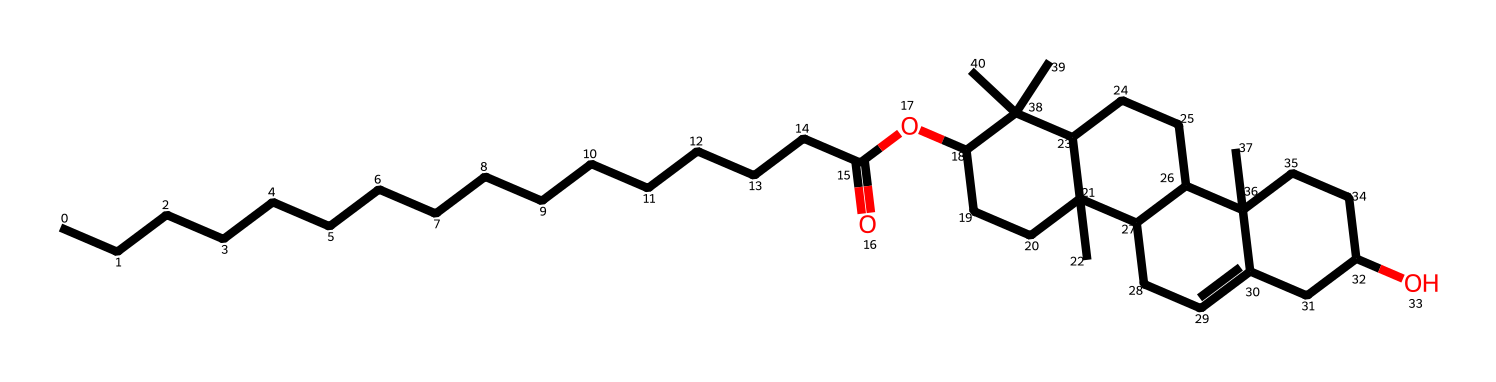What is the molecular formula of the chemical based on its structure? To deduce the molecular formula, count the number of each type of atom visible in the SMILES representation. For this structure, count the number of carbon (C), hydrogen (H), and oxygen (O) atoms, which totals to C30H50O2.
Answer: C30H50O2 How many rings are present in the chemical structure? Examine the structure to identify the presence of cyclic structures. The SMILES notation features multiple "C" that indicate cycles, and upon visualization, there are three distinct rings in the structure.
Answer: 3 What functional groups are present in this chemical? Analyze the structure to identify specific functional groups. The presence of the 'O' in the context of carbon compounds indicates an ester group (due to the acyl and alkyl parts) and the hydroxyl group is also notable. Thus, the primary functional groups are ester and alcohol.
Answer: ester, alcohol What type of lipid is represented by this structure? Assess the functions and characteristics of lipids based on the structure. Given the presence of fatty acid chains and the complex ring system, it indicates this lipid could be categorized as a wax or a complex triglyceride, specifically lanolin, which has emollient properties.
Answer: lanolin Does this molecule have any double bonds? Inspect the presence of any carbon atoms with a double bond. In the visual structure based on the SMILES, there is a cyclic compound where some C atoms participate in pi bonding, indicating the presence of a double bond.
Answer: Yes 